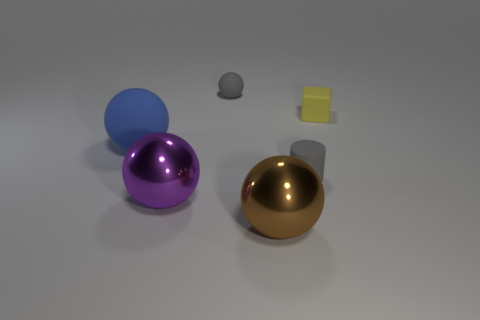Subtract all cyan balls. Subtract all brown cylinders. How many balls are left? 4 Add 3 green rubber cylinders. How many objects exist? 9 Subtract all blocks. How many objects are left? 5 Add 4 yellow blocks. How many yellow blocks exist? 5 Subtract 0 yellow cylinders. How many objects are left? 6 Subtract all tiny red rubber balls. Subtract all big spheres. How many objects are left? 3 Add 4 large brown spheres. How many large brown spheres are left? 5 